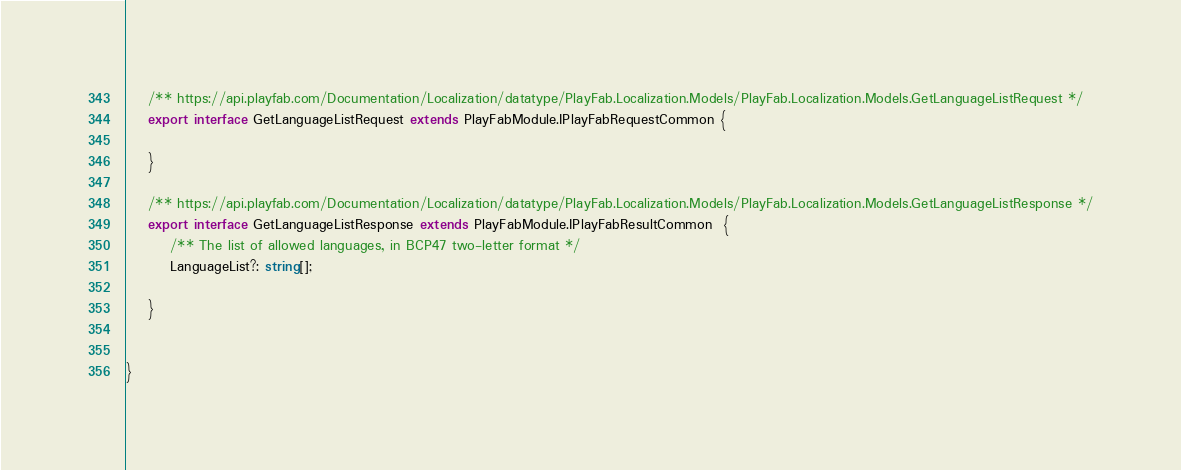<code> <loc_0><loc_0><loc_500><loc_500><_TypeScript_>    /** https://api.playfab.com/Documentation/Localization/datatype/PlayFab.Localization.Models/PlayFab.Localization.Models.GetLanguageListRequest */
    export interface GetLanguageListRequest extends PlayFabModule.IPlayFabRequestCommon {

    }

    /** https://api.playfab.com/Documentation/Localization/datatype/PlayFab.Localization.Models/PlayFab.Localization.Models.GetLanguageListResponse */
    export interface GetLanguageListResponse extends PlayFabModule.IPlayFabResultCommon  {
        /** The list of allowed languages, in BCP47 two-letter format */
        LanguageList?: string[];

    }


}
</code> 